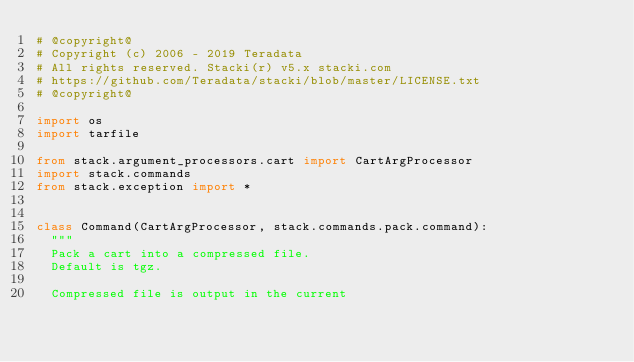Convert code to text. <code><loc_0><loc_0><loc_500><loc_500><_Python_># @copyright@
# Copyright (c) 2006 - 2019 Teradata
# All rights reserved. Stacki(r) v5.x stacki.com
# https://github.com/Teradata/stacki/blob/master/LICENSE.txt
# @copyright@

import os
import tarfile

from stack.argument_processors.cart import CartArgProcessor
import stack.commands
from stack.exception import *


class Command(CartArgProcessor, stack.commands.pack.command):
	"""
	Pack a cart into a compressed file.
	Default is tgz.

	Compressed file is output in the current </code> 